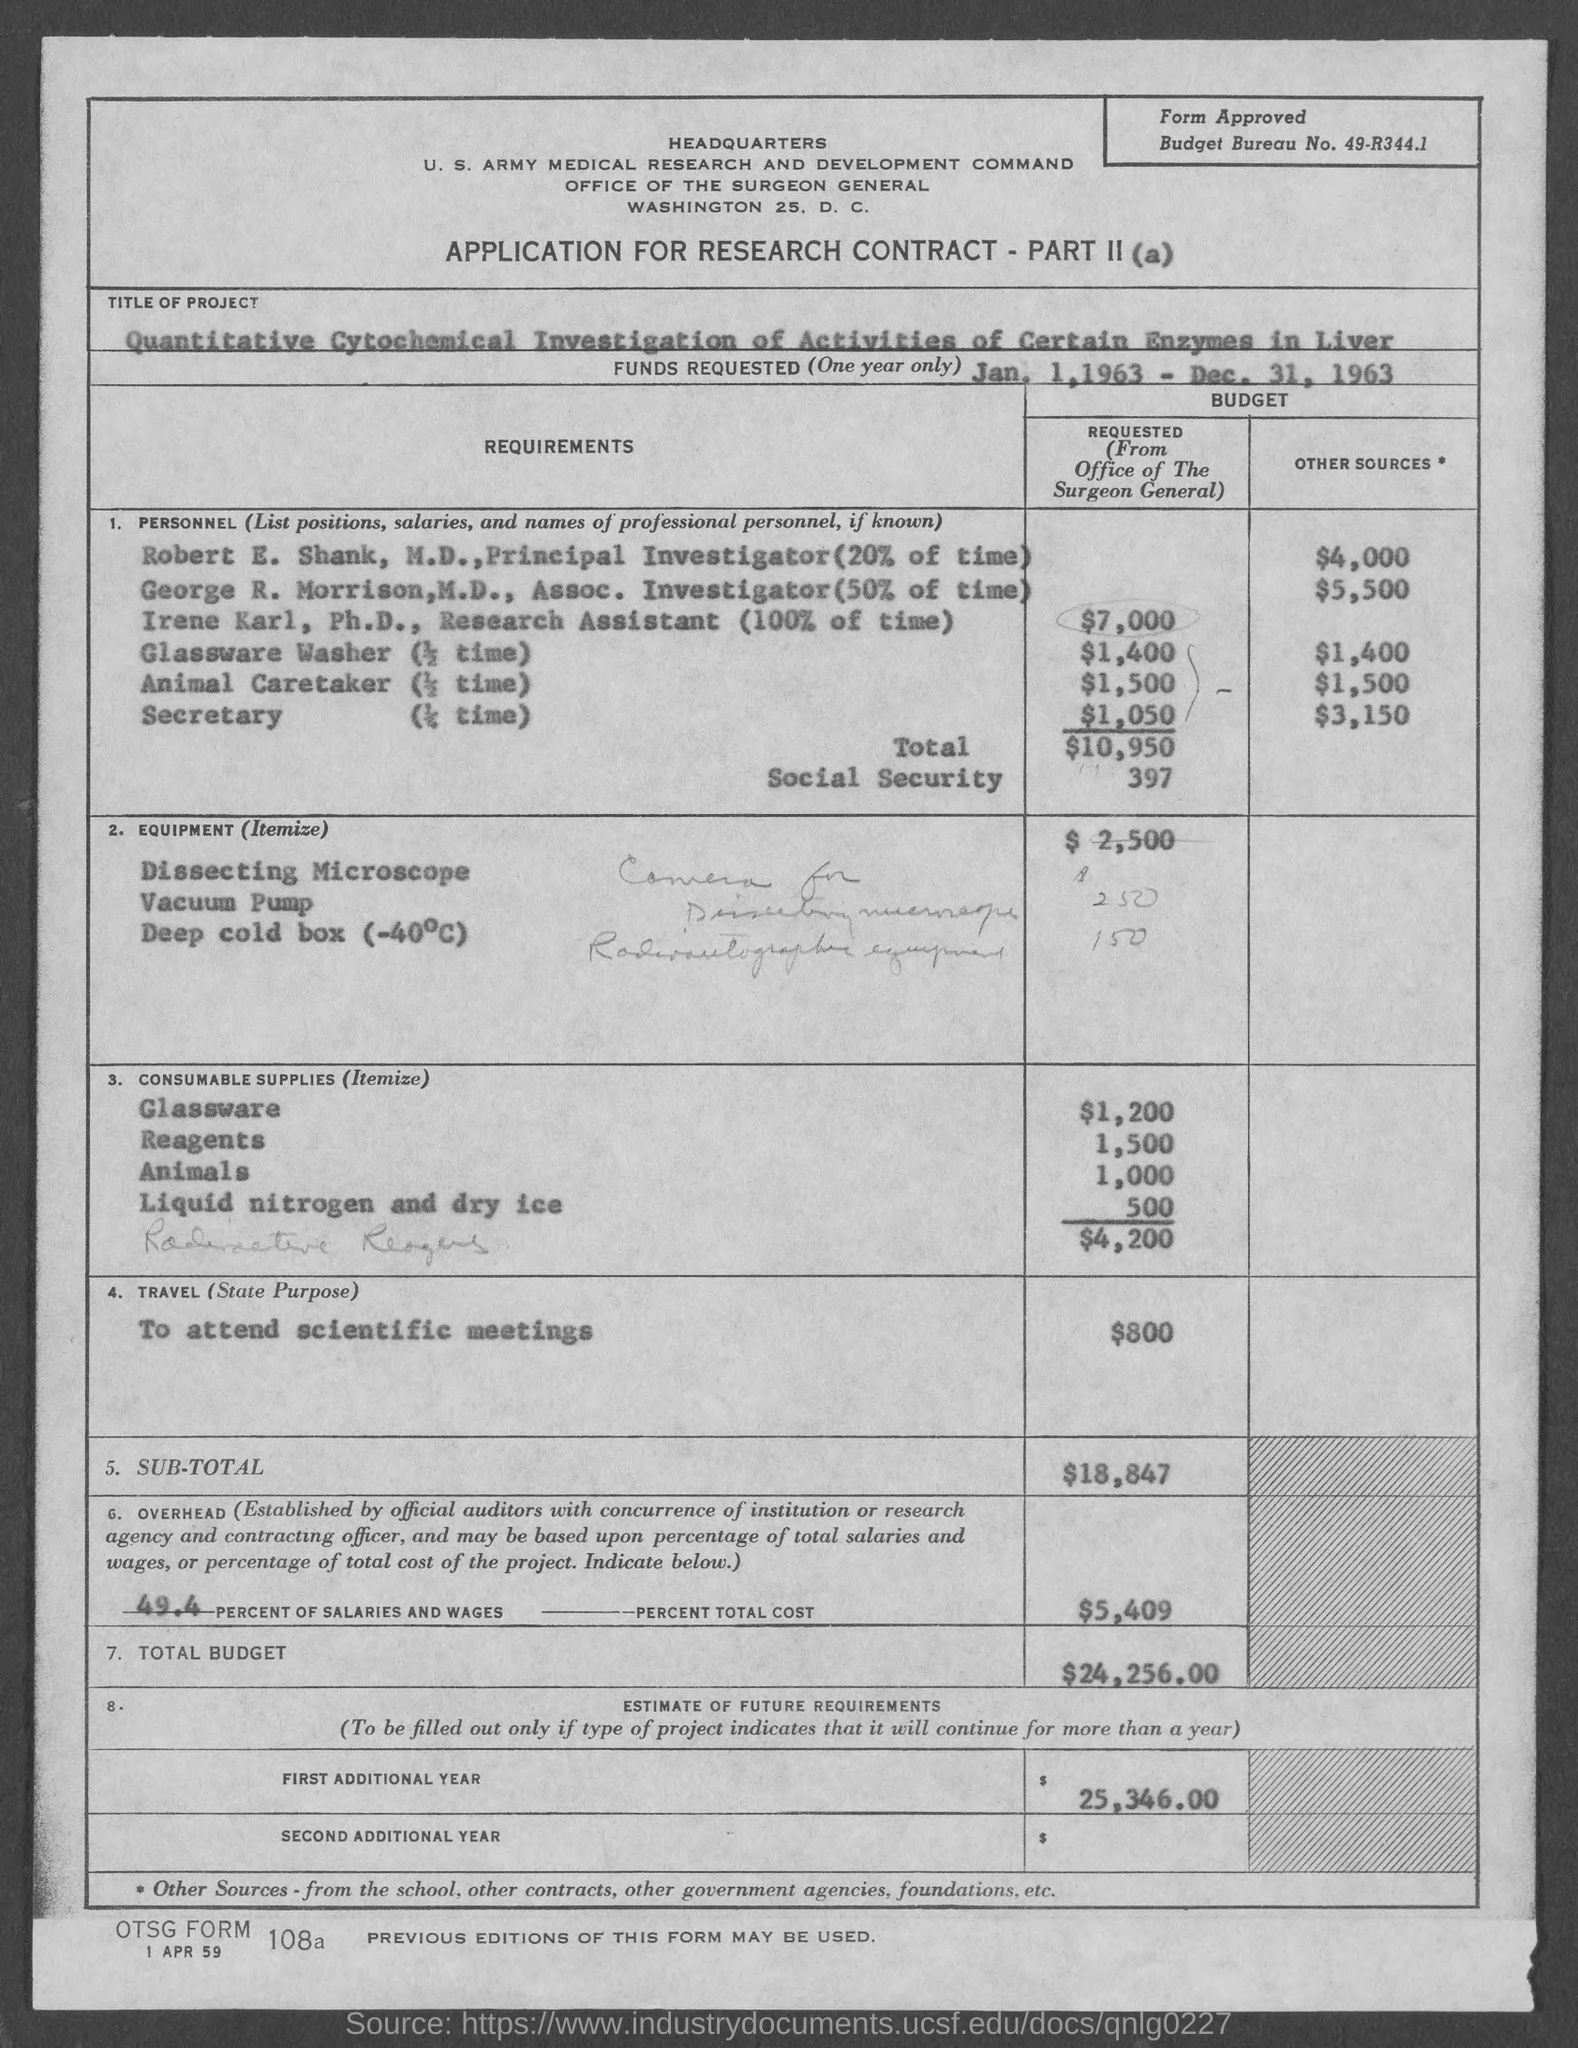What is the budget bureau no.?
Provide a short and direct response. 49-R344.1. 